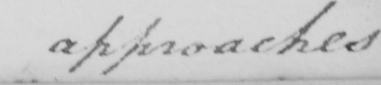Can you tell me what this handwritten text says? approaches 